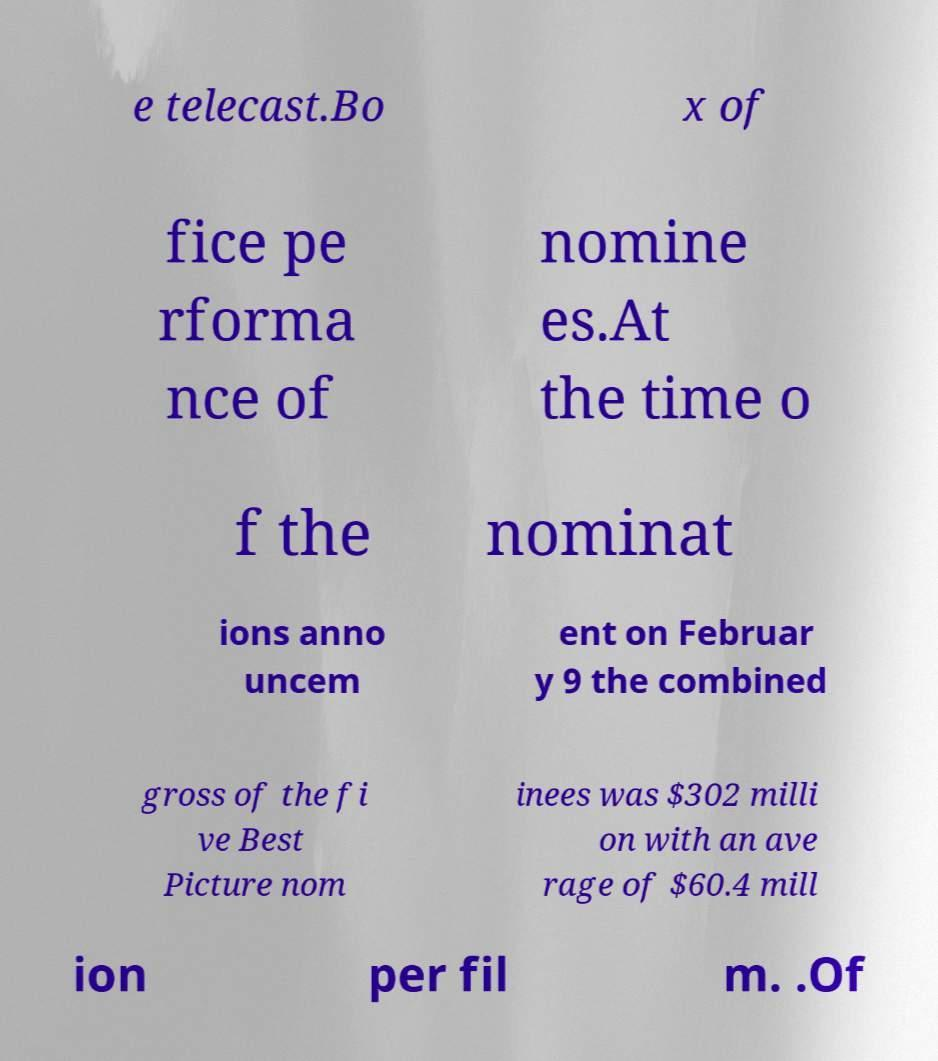Please identify and transcribe the text found in this image. e telecast.Bo x of fice pe rforma nce of nomine es.At the time o f the nominat ions anno uncem ent on Februar y 9 the combined gross of the fi ve Best Picture nom inees was $302 milli on with an ave rage of $60.4 mill ion per fil m. .Of 